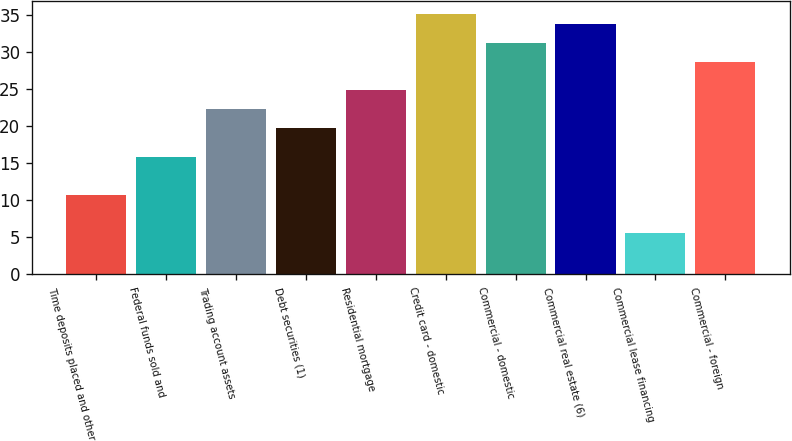Convert chart. <chart><loc_0><loc_0><loc_500><loc_500><bar_chart><fcel>Time deposits placed and other<fcel>Federal funds sold and<fcel>Trading account assets<fcel>Debt securities (1)<fcel>Residential mortgage<fcel>Credit card - domestic<fcel>Commercial - domestic<fcel>Commercial real estate (6)<fcel>Commercial lease financing<fcel>Commercial - foreign<nl><fcel>10.75<fcel>15.87<fcel>22.27<fcel>19.71<fcel>24.83<fcel>35.07<fcel>31.23<fcel>33.79<fcel>5.63<fcel>28.67<nl></chart> 